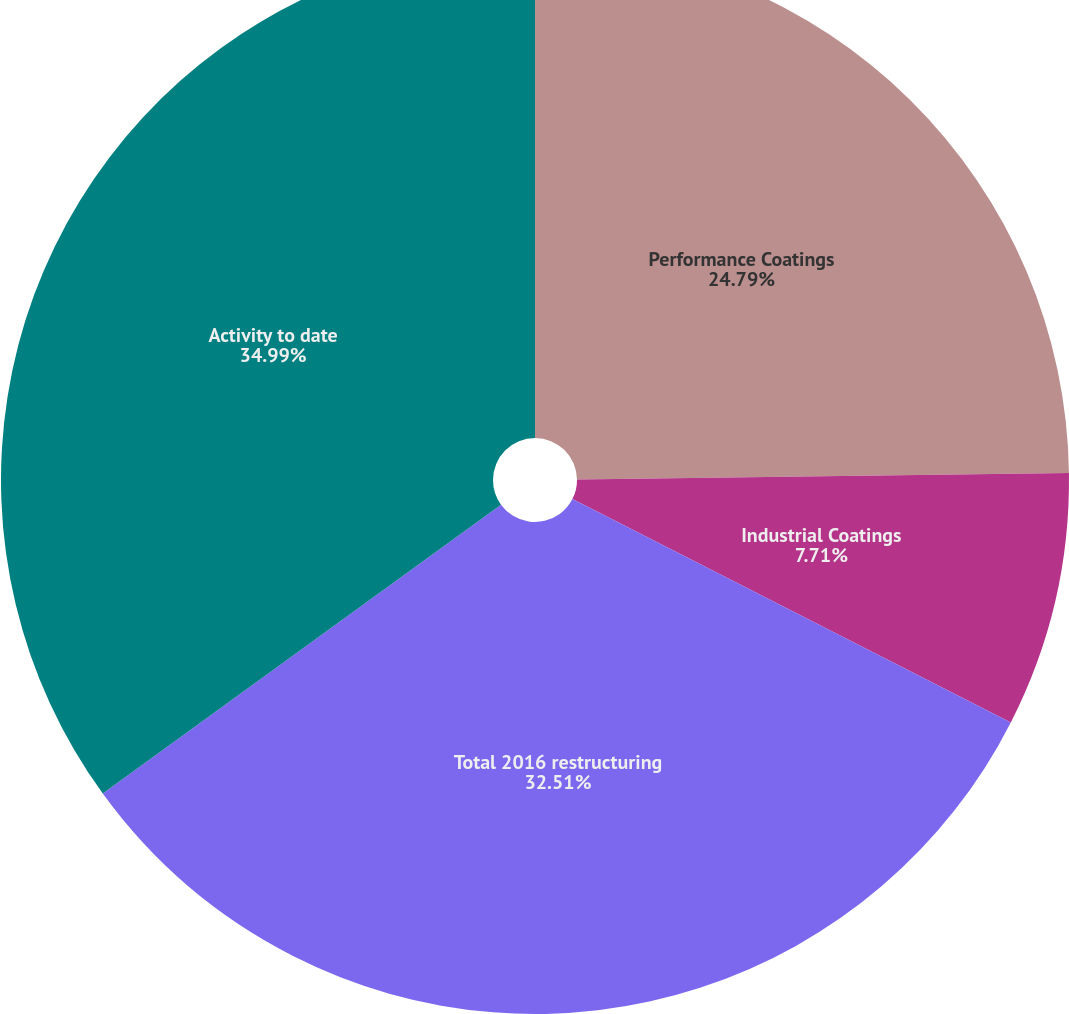Convert chart to OTSL. <chart><loc_0><loc_0><loc_500><loc_500><pie_chart><fcel>Performance Coatings<fcel>Industrial Coatings<fcel>Total 2016 restructuring<fcel>Activity to date<nl><fcel>24.79%<fcel>7.71%<fcel>32.51%<fcel>34.99%<nl></chart> 